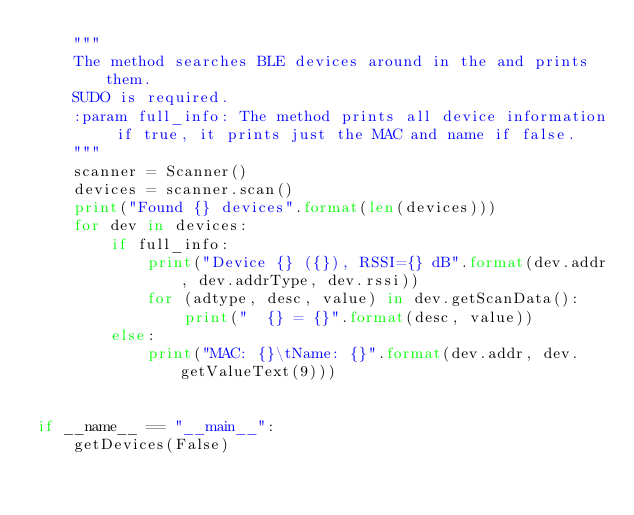<code> <loc_0><loc_0><loc_500><loc_500><_Python_>    """
    The method searches BLE devices around in the and prints them.
    SUDO is required.
    :param full_info: The method prints all device information if true, it prints just the MAC and name if false.
    """
    scanner = Scanner()
    devices = scanner.scan()
    print("Found {} devices".format(len(devices)))
    for dev in devices:
        if full_info:
            print("Device {} ({}), RSSI={} dB".format(dev.addr, dev.addrType, dev.rssi))
            for (adtype, desc, value) in dev.getScanData():
                print("  {} = {}".format(desc, value))
        else:
            print("MAC: {}\tName: {}".format(dev.addr, dev.getValueText(9)))


if __name__ == "__main__":
    getDevices(False)
</code> 